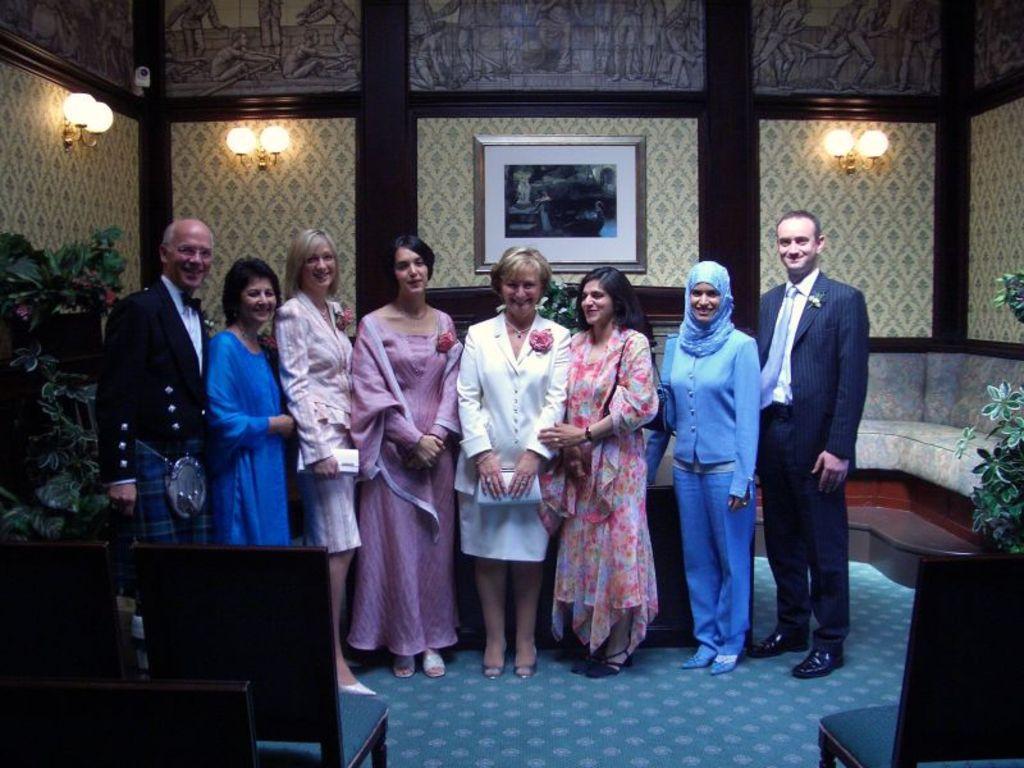Describe this image in one or two sentences. In the center of the image there are people standing. At the bottom of the image there is a carpet. To the left side of the image there are chairs. In the background of the image there is a wall. There are lights on the wall. There is a photo frame. 